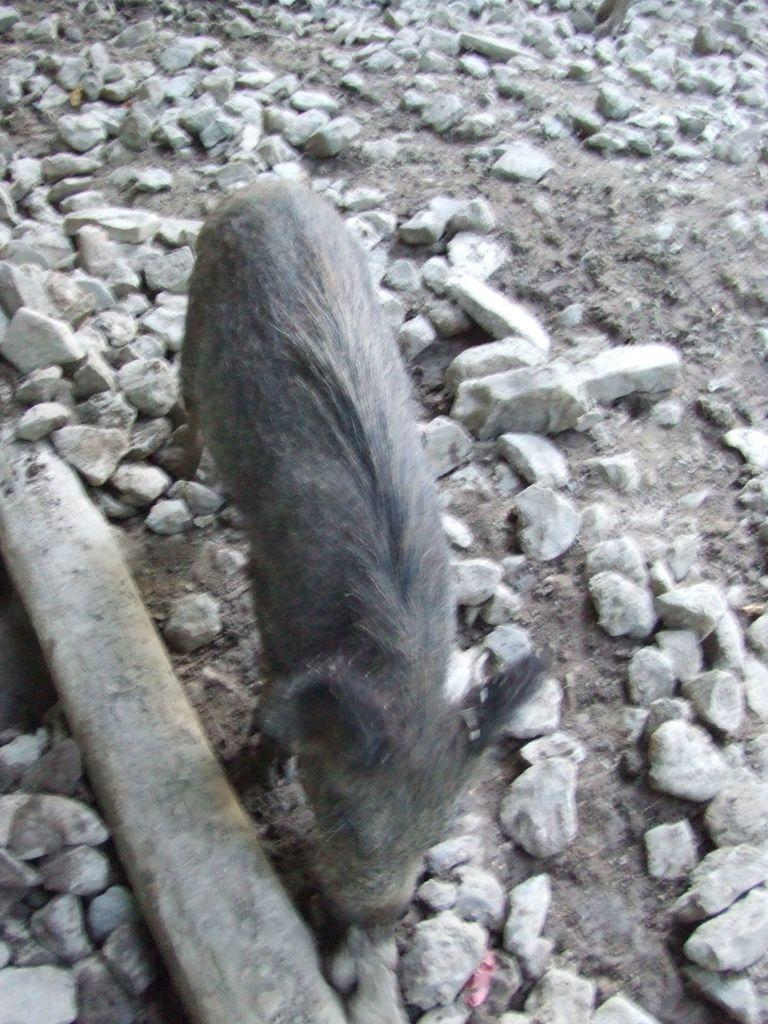What type of living creature is present in the image? There is an animal in the image. What can be seen on the ground in the image? There are stones on the ground in the image. What hobbies does the goat have, as mentioned in the caption of the image? There is no caption present in the image, and no goat is mentioned in the provided facts. 